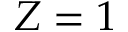Convert formula to latex. <formula><loc_0><loc_0><loc_500><loc_500>Z = 1</formula> 